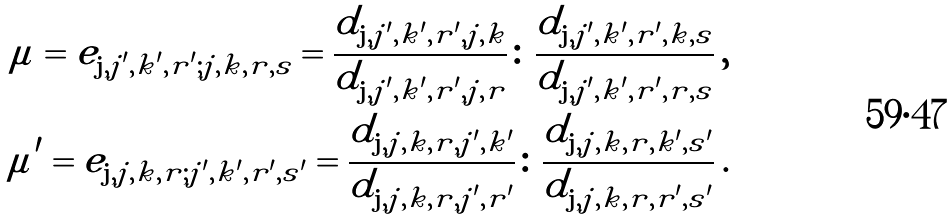Convert formula to latex. <formula><loc_0><loc_0><loc_500><loc_500>\mu = e _ { { \mathbf j } , j ^ { \prime } , k ^ { \prime } , r ^ { \prime } ; j , k , r , s } = \frac { d _ { { \mathbf j } , j ^ { \prime } , k ^ { \prime } , r ^ { \prime } , j , k } } { d _ { { \mathbf j } , j ^ { \prime } , k ^ { \prime } , r ^ { \prime } , j , r } } \colon \frac { d _ { { \mathbf j } , j ^ { \prime } , k ^ { \prime } , r ^ { \prime } , k , s } } { d _ { { \mathbf j } , j ^ { \prime } , k ^ { \prime } , r ^ { \prime } , r , s } } \, , \\ \mu ^ { \prime } = e _ { { \mathbf j } , j , k , r ; j ^ { \prime } , k ^ { \prime } , r ^ { \prime } , s ^ { \prime } } = \frac { d _ { { \mathbf j } , j , k , r , j ^ { \prime } , k ^ { \prime } } } { d _ { { \mathbf j } , j , k , r , j ^ { \prime } , r ^ { \prime } } } \colon \frac { d _ { { \mathbf j } , j , k , r , k ^ { \prime } , s ^ { \prime } } } { d _ { { \mathbf j } , j , k , r , r ^ { \prime } , s ^ { \prime } } } \, .</formula> 